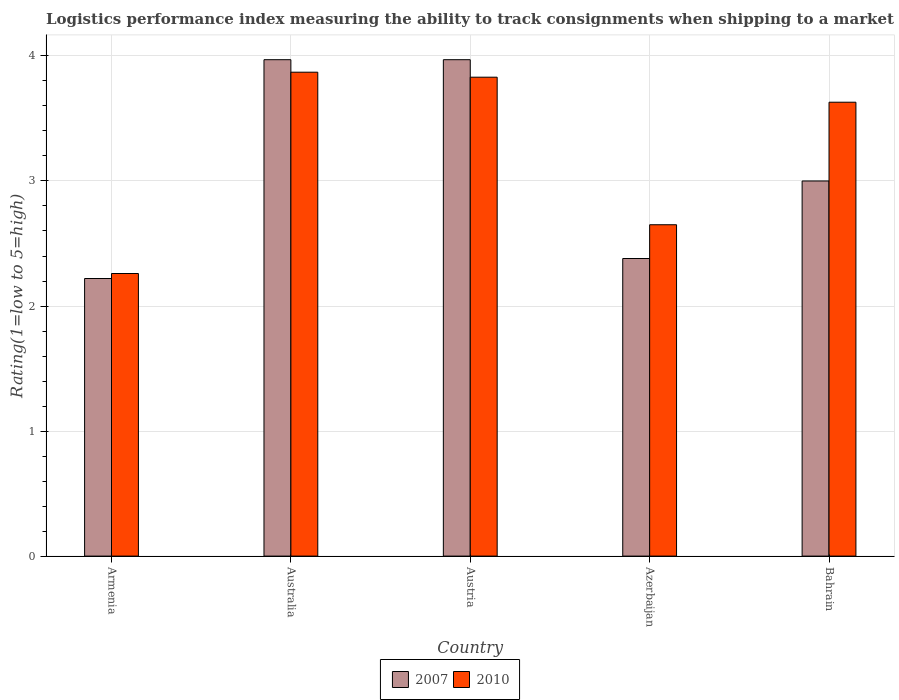How many groups of bars are there?
Your answer should be very brief. 5. How many bars are there on the 3rd tick from the left?
Your response must be concise. 2. How many bars are there on the 2nd tick from the right?
Your response must be concise. 2. What is the label of the 4th group of bars from the left?
Your answer should be very brief. Azerbaijan. What is the Logistic performance index in 2007 in Bahrain?
Provide a succinct answer. 3. Across all countries, what is the maximum Logistic performance index in 2007?
Your answer should be compact. 3.97. Across all countries, what is the minimum Logistic performance index in 2007?
Provide a succinct answer. 2.22. In which country was the Logistic performance index in 2010 maximum?
Ensure brevity in your answer.  Australia. In which country was the Logistic performance index in 2007 minimum?
Your answer should be very brief. Armenia. What is the total Logistic performance index in 2010 in the graph?
Your answer should be very brief. 16.24. What is the difference between the Logistic performance index in 2010 in Armenia and that in Austria?
Offer a terse response. -1.57. What is the difference between the Logistic performance index in 2010 in Australia and the Logistic performance index in 2007 in Azerbaijan?
Your answer should be compact. 1.49. What is the average Logistic performance index in 2007 per country?
Offer a very short reply. 3.11. What is the difference between the Logistic performance index of/in 2007 and Logistic performance index of/in 2010 in Azerbaijan?
Ensure brevity in your answer.  -0.27. Is the Logistic performance index in 2007 in Armenia less than that in Azerbaijan?
Your answer should be very brief. Yes. What is the difference between the highest and the second highest Logistic performance index in 2007?
Your answer should be compact. -0.97. What is the difference between the highest and the lowest Logistic performance index in 2010?
Give a very brief answer. 1.61. How many bars are there?
Your answer should be very brief. 10. Does the graph contain grids?
Provide a short and direct response. Yes. How many legend labels are there?
Ensure brevity in your answer.  2. How are the legend labels stacked?
Offer a very short reply. Horizontal. What is the title of the graph?
Offer a terse response. Logistics performance index measuring the ability to track consignments when shipping to a market. Does "1974" appear as one of the legend labels in the graph?
Offer a terse response. No. What is the label or title of the X-axis?
Ensure brevity in your answer.  Country. What is the label or title of the Y-axis?
Keep it short and to the point. Rating(1=low to 5=high). What is the Rating(1=low to 5=high) in 2007 in Armenia?
Keep it short and to the point. 2.22. What is the Rating(1=low to 5=high) in 2010 in Armenia?
Your response must be concise. 2.26. What is the Rating(1=low to 5=high) in 2007 in Australia?
Your answer should be compact. 3.97. What is the Rating(1=low to 5=high) of 2010 in Australia?
Make the answer very short. 3.87. What is the Rating(1=low to 5=high) in 2007 in Austria?
Make the answer very short. 3.97. What is the Rating(1=low to 5=high) in 2010 in Austria?
Provide a short and direct response. 3.83. What is the Rating(1=low to 5=high) in 2007 in Azerbaijan?
Ensure brevity in your answer.  2.38. What is the Rating(1=low to 5=high) in 2010 in Azerbaijan?
Provide a short and direct response. 2.65. What is the Rating(1=low to 5=high) of 2007 in Bahrain?
Make the answer very short. 3. What is the Rating(1=low to 5=high) in 2010 in Bahrain?
Your response must be concise. 3.63. Across all countries, what is the maximum Rating(1=low to 5=high) of 2007?
Keep it short and to the point. 3.97. Across all countries, what is the maximum Rating(1=low to 5=high) in 2010?
Offer a terse response. 3.87. Across all countries, what is the minimum Rating(1=low to 5=high) of 2007?
Give a very brief answer. 2.22. Across all countries, what is the minimum Rating(1=low to 5=high) in 2010?
Your answer should be compact. 2.26. What is the total Rating(1=low to 5=high) in 2007 in the graph?
Offer a very short reply. 15.54. What is the total Rating(1=low to 5=high) in 2010 in the graph?
Keep it short and to the point. 16.24. What is the difference between the Rating(1=low to 5=high) in 2007 in Armenia and that in Australia?
Keep it short and to the point. -1.75. What is the difference between the Rating(1=low to 5=high) of 2010 in Armenia and that in Australia?
Your response must be concise. -1.61. What is the difference between the Rating(1=low to 5=high) of 2007 in Armenia and that in Austria?
Offer a terse response. -1.75. What is the difference between the Rating(1=low to 5=high) of 2010 in Armenia and that in Austria?
Your answer should be very brief. -1.57. What is the difference between the Rating(1=low to 5=high) of 2007 in Armenia and that in Azerbaijan?
Your answer should be very brief. -0.16. What is the difference between the Rating(1=low to 5=high) in 2010 in Armenia and that in Azerbaijan?
Provide a succinct answer. -0.39. What is the difference between the Rating(1=low to 5=high) in 2007 in Armenia and that in Bahrain?
Provide a short and direct response. -0.78. What is the difference between the Rating(1=low to 5=high) in 2010 in Armenia and that in Bahrain?
Make the answer very short. -1.37. What is the difference between the Rating(1=low to 5=high) of 2007 in Australia and that in Austria?
Ensure brevity in your answer.  0. What is the difference between the Rating(1=low to 5=high) of 2007 in Australia and that in Azerbaijan?
Give a very brief answer. 1.59. What is the difference between the Rating(1=low to 5=high) of 2010 in Australia and that in Azerbaijan?
Give a very brief answer. 1.22. What is the difference between the Rating(1=low to 5=high) of 2010 in Australia and that in Bahrain?
Your answer should be very brief. 0.24. What is the difference between the Rating(1=low to 5=high) of 2007 in Austria and that in Azerbaijan?
Your answer should be compact. 1.59. What is the difference between the Rating(1=low to 5=high) in 2010 in Austria and that in Azerbaijan?
Your response must be concise. 1.18. What is the difference between the Rating(1=low to 5=high) of 2010 in Austria and that in Bahrain?
Your answer should be very brief. 0.2. What is the difference between the Rating(1=low to 5=high) of 2007 in Azerbaijan and that in Bahrain?
Provide a short and direct response. -0.62. What is the difference between the Rating(1=low to 5=high) in 2010 in Azerbaijan and that in Bahrain?
Provide a succinct answer. -0.98. What is the difference between the Rating(1=low to 5=high) of 2007 in Armenia and the Rating(1=low to 5=high) of 2010 in Australia?
Make the answer very short. -1.65. What is the difference between the Rating(1=low to 5=high) of 2007 in Armenia and the Rating(1=low to 5=high) of 2010 in Austria?
Your response must be concise. -1.61. What is the difference between the Rating(1=low to 5=high) of 2007 in Armenia and the Rating(1=low to 5=high) of 2010 in Azerbaijan?
Offer a terse response. -0.43. What is the difference between the Rating(1=low to 5=high) in 2007 in Armenia and the Rating(1=low to 5=high) in 2010 in Bahrain?
Make the answer very short. -1.41. What is the difference between the Rating(1=low to 5=high) in 2007 in Australia and the Rating(1=low to 5=high) in 2010 in Austria?
Your answer should be compact. 0.14. What is the difference between the Rating(1=low to 5=high) in 2007 in Australia and the Rating(1=low to 5=high) in 2010 in Azerbaijan?
Offer a terse response. 1.32. What is the difference between the Rating(1=low to 5=high) in 2007 in Australia and the Rating(1=low to 5=high) in 2010 in Bahrain?
Provide a short and direct response. 0.34. What is the difference between the Rating(1=low to 5=high) of 2007 in Austria and the Rating(1=low to 5=high) of 2010 in Azerbaijan?
Offer a terse response. 1.32. What is the difference between the Rating(1=low to 5=high) in 2007 in Austria and the Rating(1=low to 5=high) in 2010 in Bahrain?
Offer a very short reply. 0.34. What is the difference between the Rating(1=low to 5=high) in 2007 in Azerbaijan and the Rating(1=low to 5=high) in 2010 in Bahrain?
Ensure brevity in your answer.  -1.25. What is the average Rating(1=low to 5=high) of 2007 per country?
Make the answer very short. 3.11. What is the average Rating(1=low to 5=high) of 2010 per country?
Provide a succinct answer. 3.25. What is the difference between the Rating(1=low to 5=high) of 2007 and Rating(1=low to 5=high) of 2010 in Armenia?
Provide a short and direct response. -0.04. What is the difference between the Rating(1=low to 5=high) of 2007 and Rating(1=low to 5=high) of 2010 in Austria?
Make the answer very short. 0.14. What is the difference between the Rating(1=low to 5=high) in 2007 and Rating(1=low to 5=high) in 2010 in Azerbaijan?
Your answer should be very brief. -0.27. What is the difference between the Rating(1=low to 5=high) in 2007 and Rating(1=low to 5=high) in 2010 in Bahrain?
Offer a very short reply. -0.63. What is the ratio of the Rating(1=low to 5=high) of 2007 in Armenia to that in Australia?
Your answer should be very brief. 0.56. What is the ratio of the Rating(1=low to 5=high) in 2010 in Armenia to that in Australia?
Offer a terse response. 0.58. What is the ratio of the Rating(1=low to 5=high) in 2007 in Armenia to that in Austria?
Your response must be concise. 0.56. What is the ratio of the Rating(1=low to 5=high) of 2010 in Armenia to that in Austria?
Ensure brevity in your answer.  0.59. What is the ratio of the Rating(1=low to 5=high) in 2007 in Armenia to that in Azerbaijan?
Provide a short and direct response. 0.93. What is the ratio of the Rating(1=low to 5=high) in 2010 in Armenia to that in Azerbaijan?
Make the answer very short. 0.85. What is the ratio of the Rating(1=low to 5=high) in 2007 in Armenia to that in Bahrain?
Keep it short and to the point. 0.74. What is the ratio of the Rating(1=low to 5=high) in 2010 in Armenia to that in Bahrain?
Your answer should be very brief. 0.62. What is the ratio of the Rating(1=low to 5=high) of 2007 in Australia to that in Austria?
Give a very brief answer. 1. What is the ratio of the Rating(1=low to 5=high) of 2010 in Australia to that in Austria?
Offer a very short reply. 1.01. What is the ratio of the Rating(1=low to 5=high) in 2007 in Australia to that in Azerbaijan?
Provide a short and direct response. 1.67. What is the ratio of the Rating(1=low to 5=high) of 2010 in Australia to that in Azerbaijan?
Your response must be concise. 1.46. What is the ratio of the Rating(1=low to 5=high) in 2007 in Australia to that in Bahrain?
Ensure brevity in your answer.  1.32. What is the ratio of the Rating(1=low to 5=high) in 2010 in Australia to that in Bahrain?
Offer a terse response. 1.07. What is the ratio of the Rating(1=low to 5=high) of 2007 in Austria to that in Azerbaijan?
Keep it short and to the point. 1.67. What is the ratio of the Rating(1=low to 5=high) in 2010 in Austria to that in Azerbaijan?
Your answer should be very brief. 1.45. What is the ratio of the Rating(1=low to 5=high) in 2007 in Austria to that in Bahrain?
Provide a short and direct response. 1.32. What is the ratio of the Rating(1=low to 5=high) in 2010 in Austria to that in Bahrain?
Provide a short and direct response. 1.06. What is the ratio of the Rating(1=low to 5=high) in 2007 in Azerbaijan to that in Bahrain?
Make the answer very short. 0.79. What is the ratio of the Rating(1=low to 5=high) in 2010 in Azerbaijan to that in Bahrain?
Give a very brief answer. 0.73. What is the difference between the highest and the second highest Rating(1=low to 5=high) in 2007?
Your answer should be compact. 0. What is the difference between the highest and the second highest Rating(1=low to 5=high) of 2010?
Your answer should be compact. 0.04. What is the difference between the highest and the lowest Rating(1=low to 5=high) of 2007?
Your response must be concise. 1.75. What is the difference between the highest and the lowest Rating(1=low to 5=high) of 2010?
Your response must be concise. 1.61. 